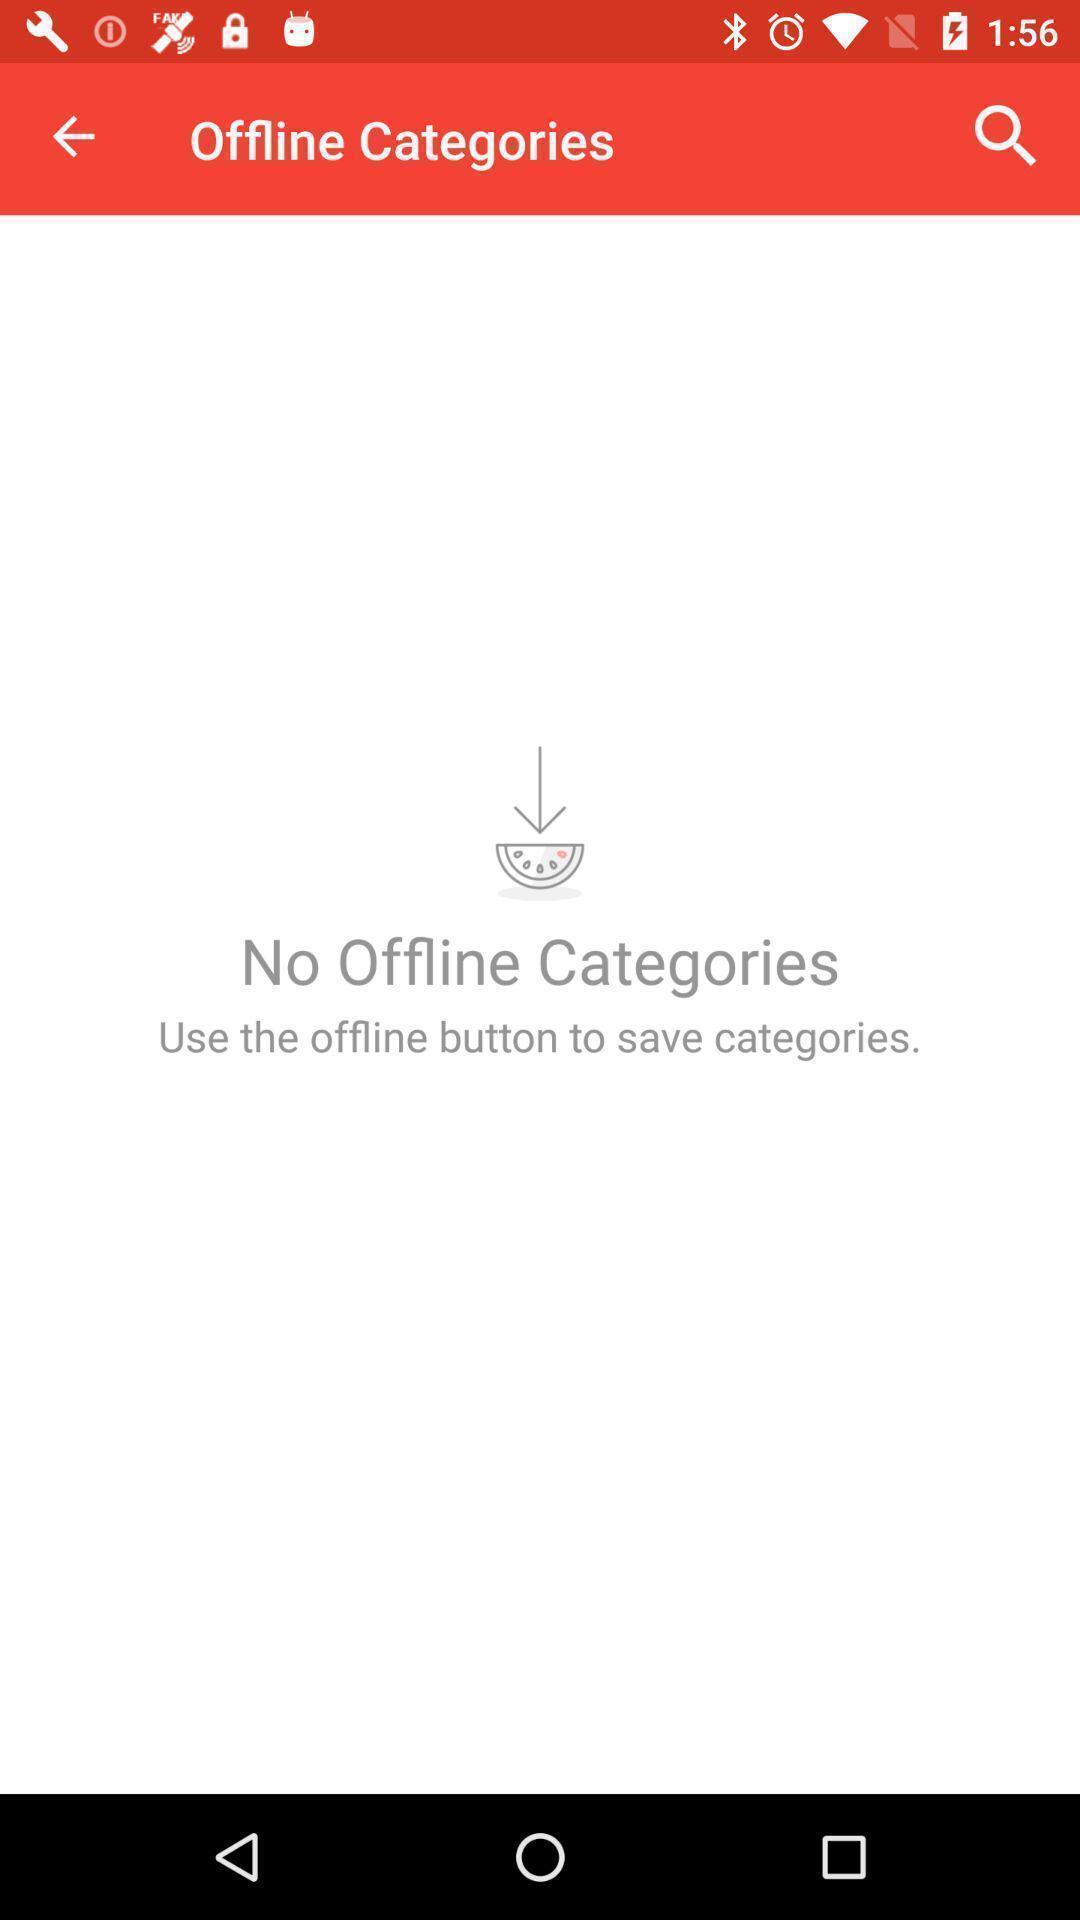Provide a description of this screenshot. Screen showing no offline categories. 